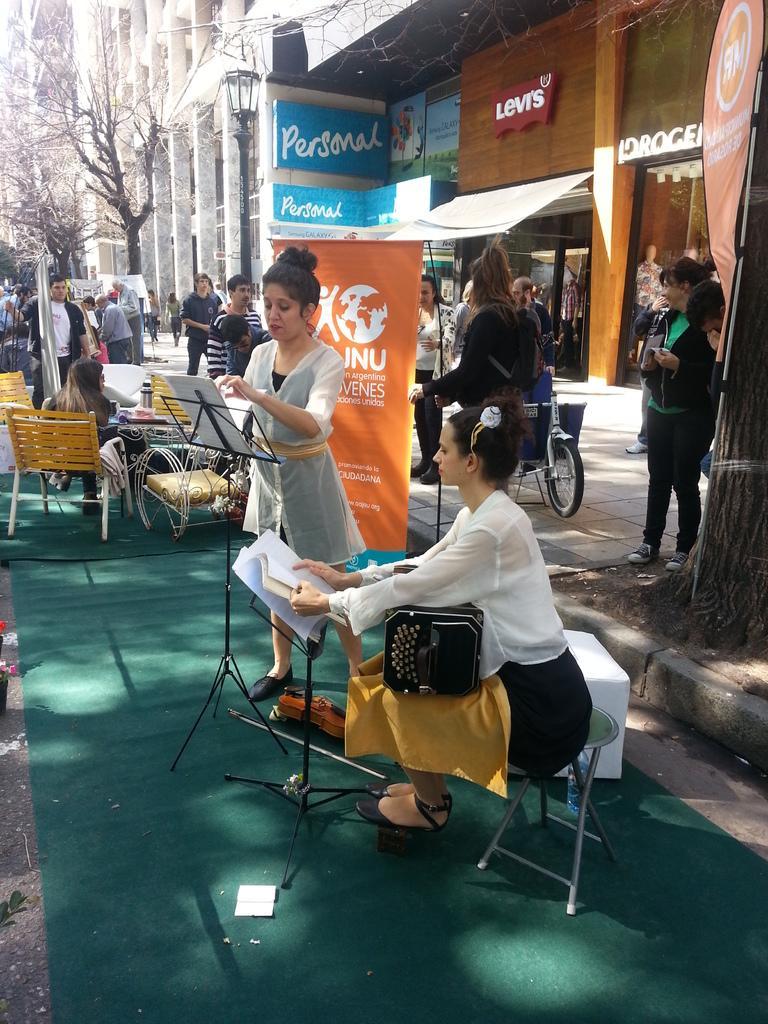In one or two sentences, can you explain what this image depicts? In this image I can see number of people and also few trees over here. Here I can see number of buildings. 